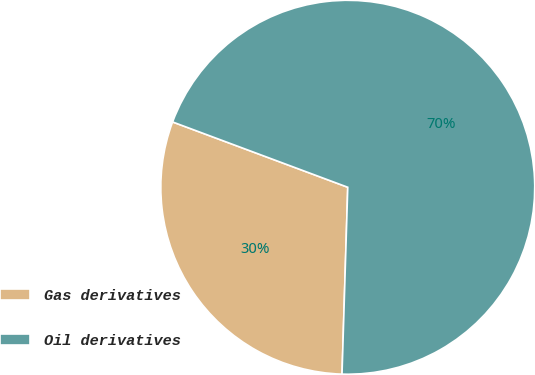Convert chart to OTSL. <chart><loc_0><loc_0><loc_500><loc_500><pie_chart><fcel>Gas derivatives<fcel>Oil derivatives<nl><fcel>30.19%<fcel>69.81%<nl></chart> 